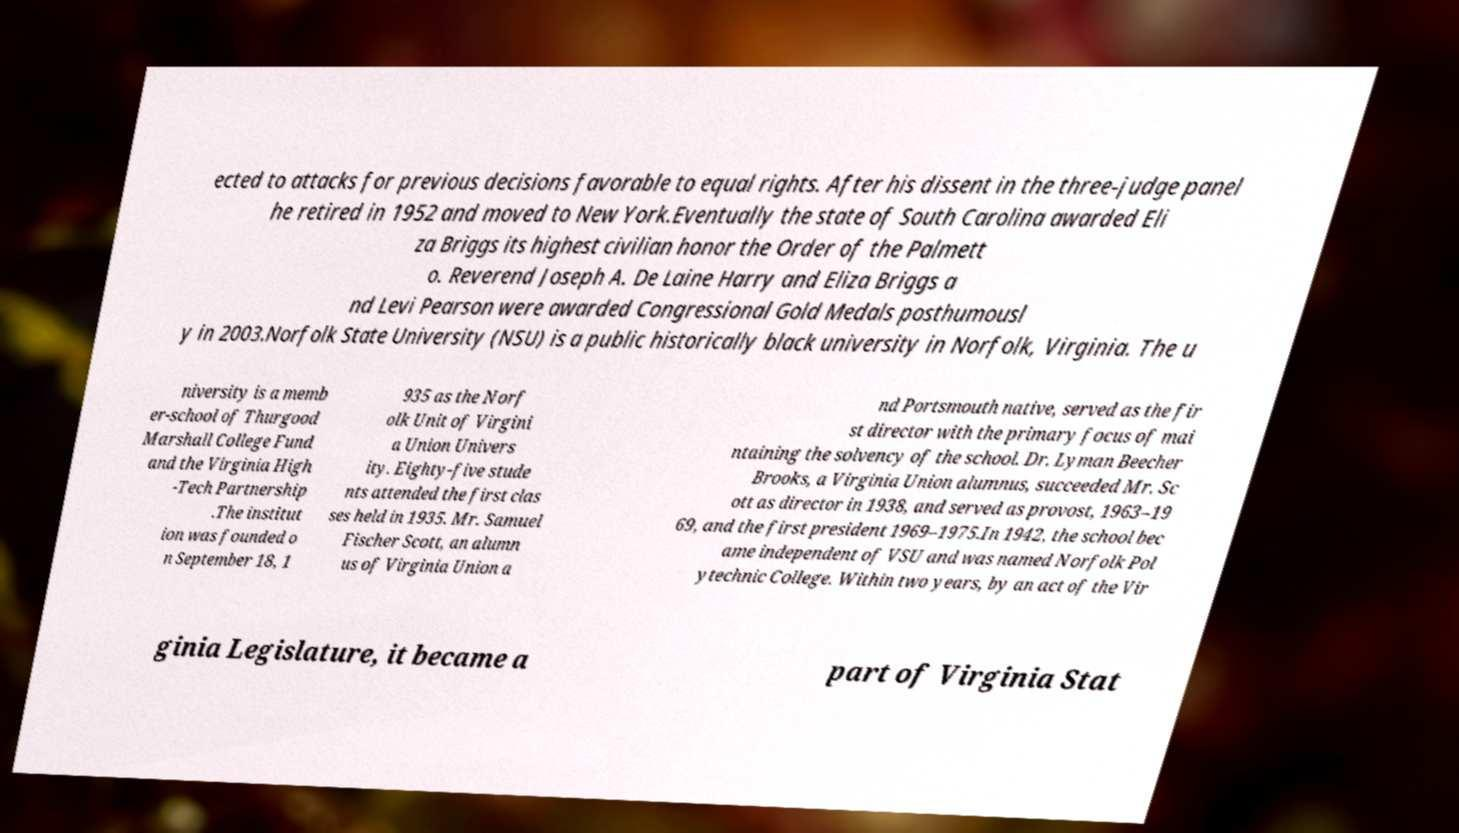Can you accurately transcribe the text from the provided image for me? ected to attacks for previous decisions favorable to equal rights. After his dissent in the three-judge panel he retired in 1952 and moved to New York.Eventually the state of South Carolina awarded Eli za Briggs its highest civilian honor the Order of the Palmett o. Reverend Joseph A. De Laine Harry and Eliza Briggs a nd Levi Pearson were awarded Congressional Gold Medals posthumousl y in 2003.Norfolk State University (NSU) is a public historically black university in Norfolk, Virginia. The u niversity is a memb er-school of Thurgood Marshall College Fund and the Virginia High -Tech Partnership .The institut ion was founded o n September 18, 1 935 as the Norf olk Unit of Virgini a Union Univers ity. Eighty-five stude nts attended the first clas ses held in 1935. Mr. Samuel Fischer Scott, an alumn us of Virginia Union a nd Portsmouth native, served as the fir st director with the primary focus of mai ntaining the solvency of the school. Dr. Lyman Beecher Brooks, a Virginia Union alumnus, succeeded Mr. Sc ott as director in 1938, and served as provost, 1963–19 69, and the first president 1969–1975.In 1942, the school bec ame independent of VSU and was named Norfolk Pol ytechnic College. Within two years, by an act of the Vir ginia Legislature, it became a part of Virginia Stat 